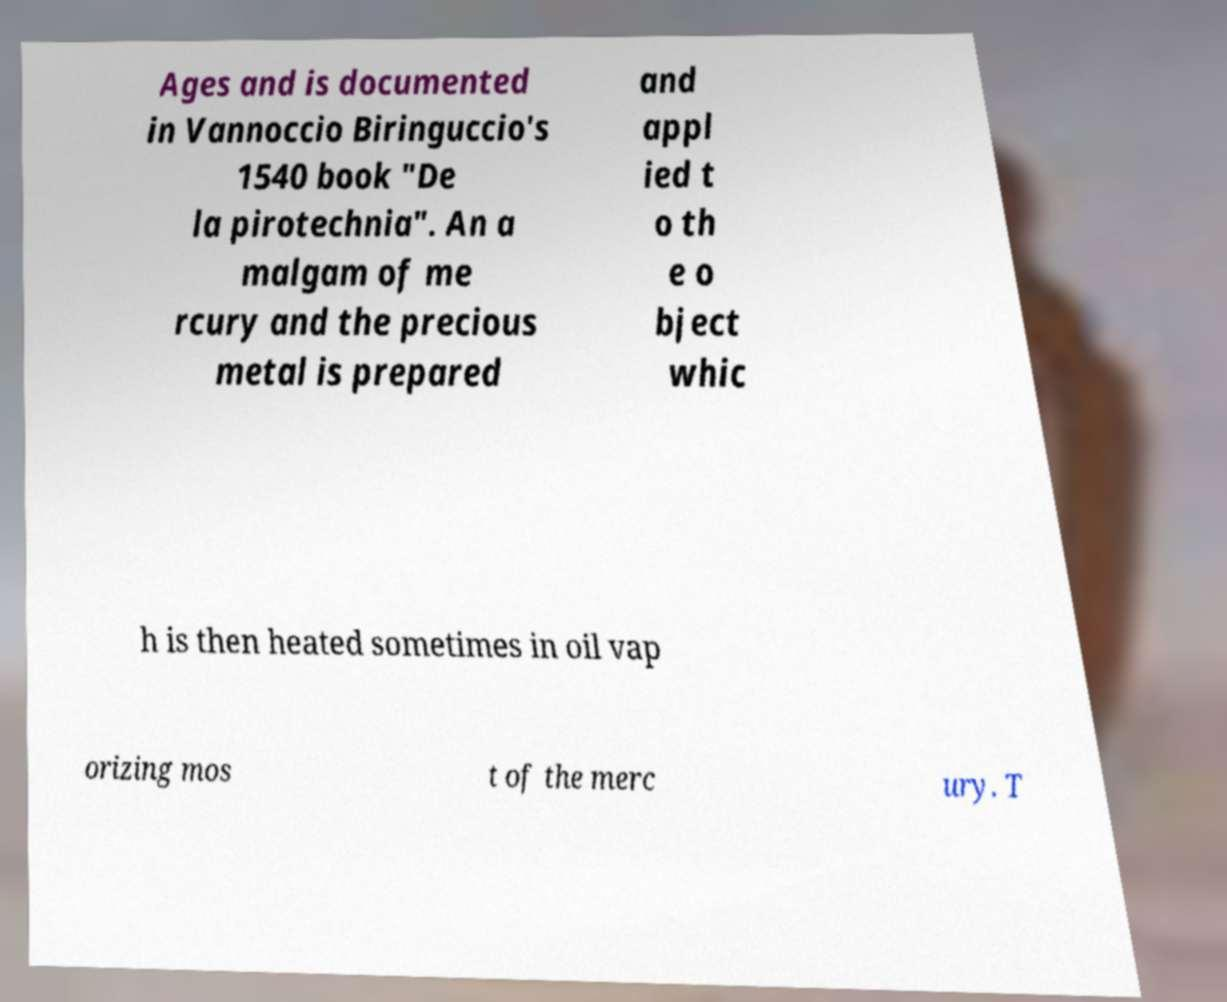Could you extract and type out the text from this image? Ages and is documented in Vannoccio Biringuccio's 1540 book "De la pirotechnia". An a malgam of me rcury and the precious metal is prepared and appl ied t o th e o bject whic h is then heated sometimes in oil vap orizing mos t of the merc ury. T 